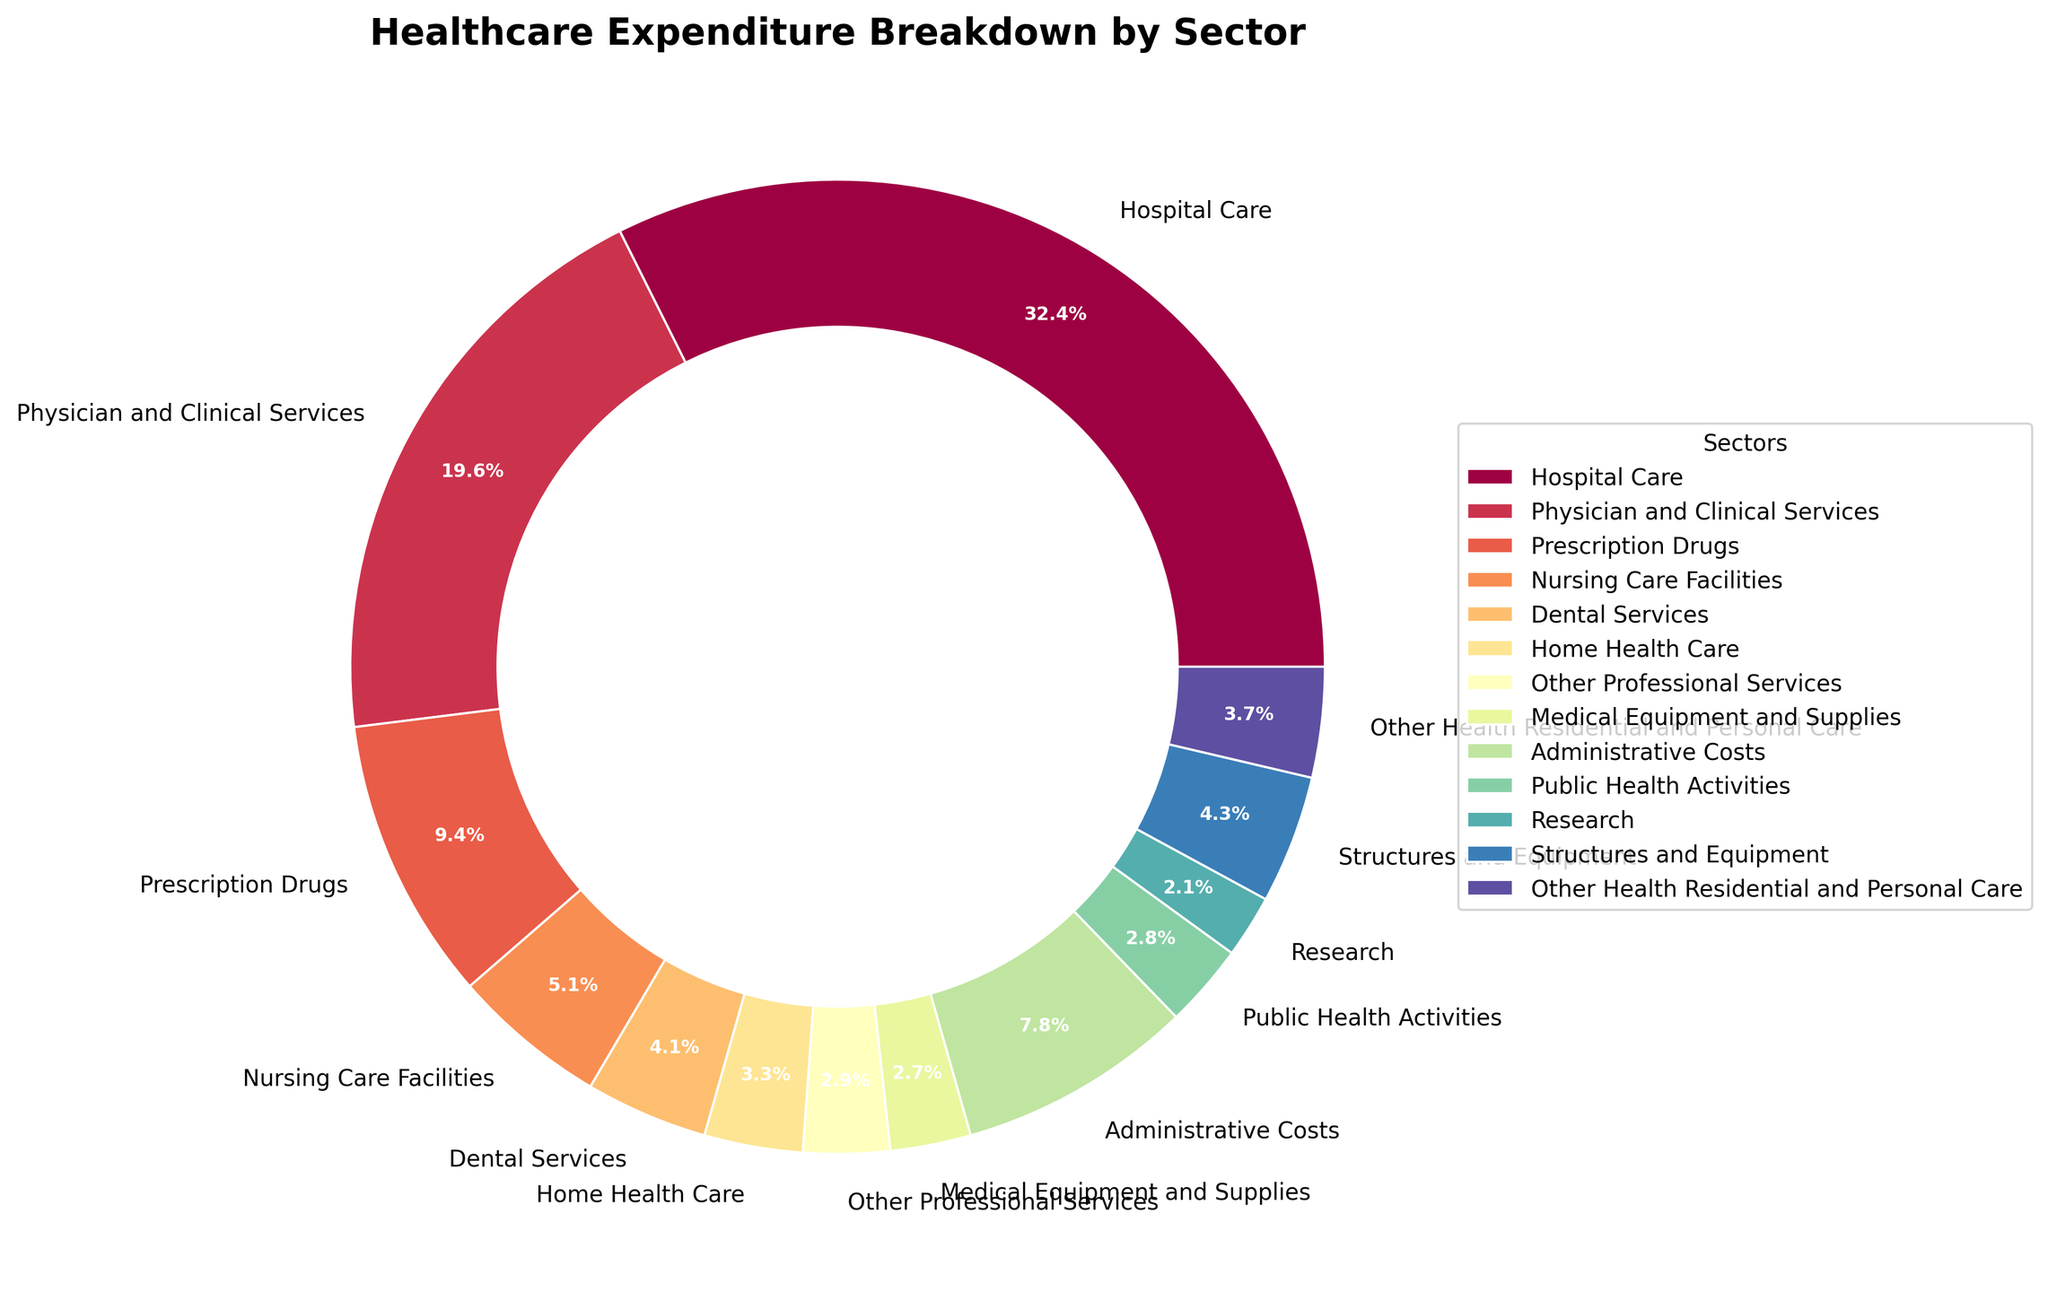Which sector has the highest healthcare expenditure percentage? Looking at the pie chart, the sector with the largest wedge represents the highest percentage. This is colored prominently and takes up the most space.
Answer: Hospital Care Which sectors combined account for more than 50% of healthcare expenditure? To tackle this, identify the sectors with large percentages and sum them until the total exceeds 50%. Hospital Care (32.7%) + Physician and Clinical Services (19.8%) = 52.5%, which is over 50%.
Answer: Hospital Care and Physician and Clinical Services What percentage of healthcare spending is attributed to Nursing Care Facilities compared to Public Health Activities? Compare the two sectors' percentages: Nursing Care Facilities (5.2%) versus Public Health Activities (2.8%).
Answer: Nursing Care Facilities (5.2%) > Public Health Activities (2.8%) How much more is spent on Administrative Costs than Medical Equipment and Supplies? Subtract the percentage of Medical Equipment and Supplies (2.7%) from that of Administrative Costs (7.9%) to find the difference. 7.9% - 2.7% = 5.2%
Answer: 5.2% What is the combined expenditure percentage for Prescription Drugs, Research, and Other Health Residential and Personal Care? Sum the percentage values for Prescription Drugs (9.5%), Research (2.1%), and Other Health Residential and Personal Care (3.7%). 9.5% + 2.1% + 3.7% = 15.3%
Answer: 15.3% Which sector has a higher expenditure: Dental Services or Home Health Care? Directly compare the percentages: Dental Services (4.1%) versus Home Health Care (3.3%).
Answer: Dental Services What is the difference in healthcare expenditure percentage between Structures and Equipment and Other Professional Services? Subtract the percentage of Other Professional Services (2.9%) from that of Structures and Equipment (4.3%). 4.3% - 2.9% = 1.4%
Answer: 1.4% How much does the expenditure on Physician and Clinical Services exceed that on Prescription Drugs? Subtract Prescription Drugs' percentage (9.5%) from Physician and Clinical Services' percentage (19.8%). 19.8% - 9.5% = 10.3%
Answer: 10.3% Which three sectors have the lowest healthcare expenditure percentages? Identify the three smallest percentages: Research (2.1%), Public Health Activities (2.8%), and Other Professional Services (2.9%).
Answer: Research, Public Health Activities, and Other Professional Services 